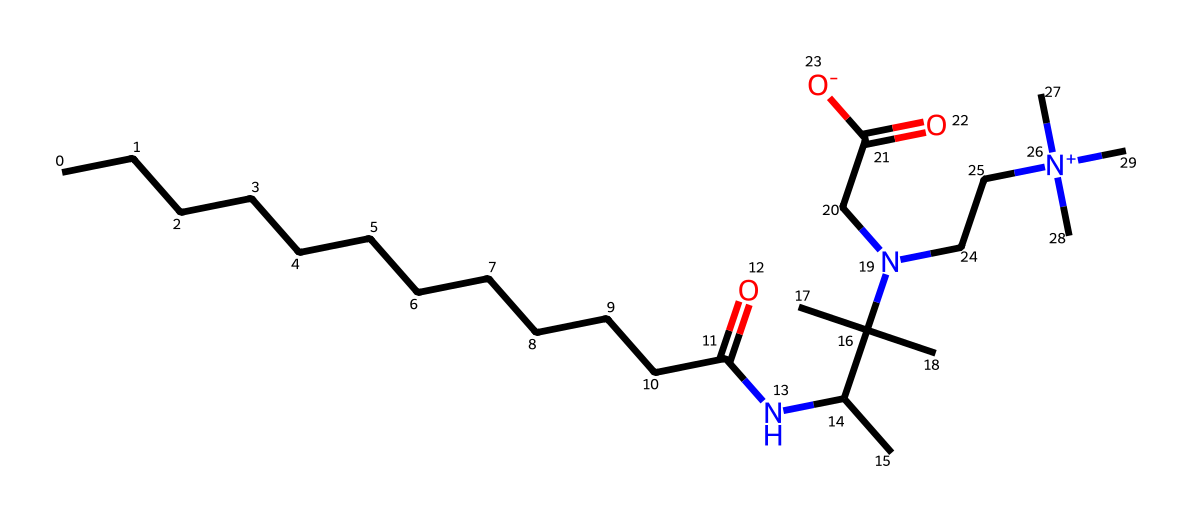How many carbon atoms are present in the structure? Counting the carbon atoms in the provided SMILES representation, there are a total of 18 carbon atoms (CCCCCCCCCCCC indicates 12 carbons, and there are additional groups contributing to the carbon count).
Answer: 18 What type of functional group is present in this chemical? The structure shows the presence of an amide functional group (indicated by the NC(=O) part). This is a characteristic of surfactants like cocamidopropyl betaine.
Answer: amide How many nitrogen atoms are present in the structure? Looking at the SMILES representation, there are 3 nitrogen atoms (one from the amide and two from the quaternary ammonium group).
Answer: 3 What is the charge of the surfactant's nitrogen atom in the quaternary ammonium part? The nitrogen in the quaternary ammonium section (N+) denotes that it has a positive charge, which is typical for this type of surfactant, enhancing its interaction with water.
Answer: positive Why is this compound classified as a gentle surfactant? The presence of the betaine structure, which combines both hydrophilic (water-attracting) and hydrophobic (water-repelling) characteristics due to the presence of a quaternary ammonium group and an amide, makes it a mild surfactant suitable for sensitive skin.
Answer: mild What role does the long hydrocarbon chain play in this detergent? The long hydrocarbon chain (CCCCCCCCCCCC) contributes to the hydrophobic part of the surfactant, enabling the compound to effectively interact with oils and dirt, thus enhancing its cleaning ability.
Answer: cleaning ability What indicates that this surfactant is eco-friendly? The usage of natural sources (coconut oil for fatty acids, as indicated by the long carbon chain and the structural components) hints at its eco-friendly attribute, differentiating it from harsher synthetic surfactants.
Answer: natural sources 